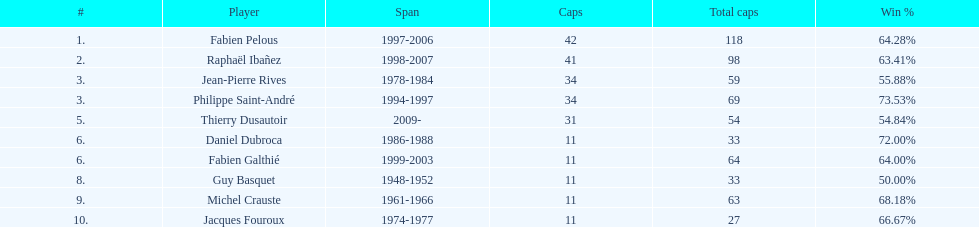Give me the full table as a dictionary. {'header': ['#', 'Player', 'Span', 'Caps', 'Total caps', 'Win\xa0%'], 'rows': [['1.', 'Fabien Pelous', '1997-2006', '42', '118', '64.28%'], ['2.', 'Raphaël Ibañez', '1998-2007', '41', '98', '63.41%'], ['3.', 'Jean-Pierre Rives', '1978-1984', '34', '59', '55.88%'], ['3.', 'Philippe Saint-André', '1994-1997', '34', '69', '73.53%'], ['5.', 'Thierry Dusautoir', '2009-', '31', '54', '54.84%'], ['6.', 'Daniel Dubroca', '1986-1988', '11', '33', '72.00%'], ['6.', 'Fabien Galthié', '1999-2003', '11', '64', '64.00%'], ['8.', 'Guy Basquet', '1948-1952', '11', '33', '50.00%'], ['9.', 'Michel Crauste', '1961-1966', '11', '63', '68.18%'], ['10.', 'Jacques Fouroux', '1974-1977', '11', '27', '66.67%']]} Which captain served the least amount of time? Daniel Dubroca. 